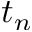<formula> <loc_0><loc_0><loc_500><loc_500>t _ { n }</formula> 